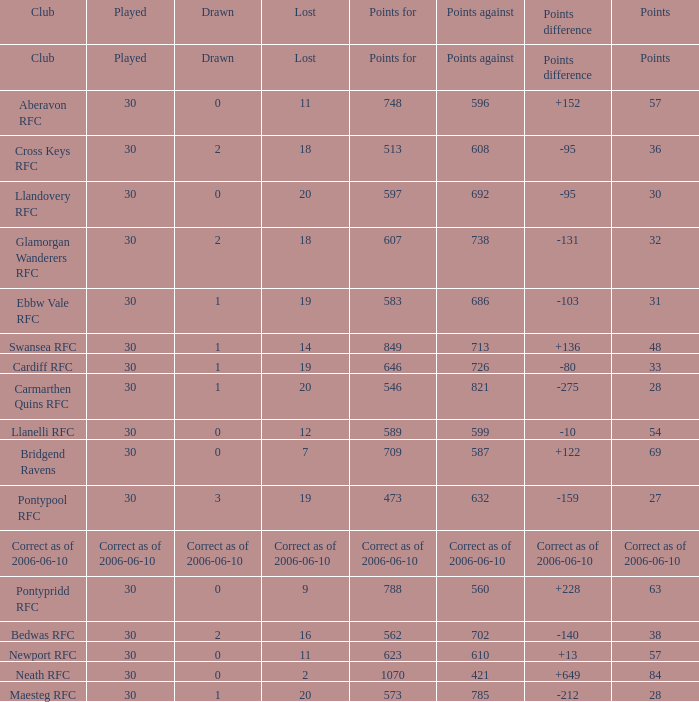What is Drawn, when Points Against is "686"? 1.0. 